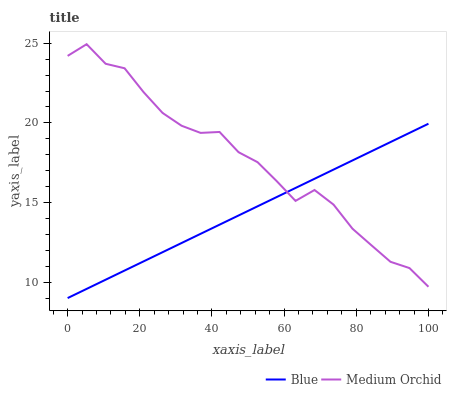Does Blue have the minimum area under the curve?
Answer yes or no. Yes. Does Medium Orchid have the maximum area under the curve?
Answer yes or no. Yes. Does Medium Orchid have the minimum area under the curve?
Answer yes or no. No. Is Blue the smoothest?
Answer yes or no. Yes. Is Medium Orchid the roughest?
Answer yes or no. Yes. Is Medium Orchid the smoothest?
Answer yes or no. No. Does Blue have the lowest value?
Answer yes or no. Yes. Does Medium Orchid have the lowest value?
Answer yes or no. No. Does Medium Orchid have the highest value?
Answer yes or no. Yes. Does Medium Orchid intersect Blue?
Answer yes or no. Yes. Is Medium Orchid less than Blue?
Answer yes or no. No. Is Medium Orchid greater than Blue?
Answer yes or no. No. 